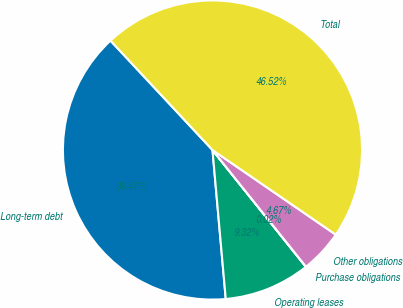<chart> <loc_0><loc_0><loc_500><loc_500><pie_chart><fcel>Long-term debt<fcel>Operating leases<fcel>Purchase obligations<fcel>Other obligations<fcel>Total<nl><fcel>39.47%<fcel>9.32%<fcel>0.02%<fcel>4.67%<fcel>46.52%<nl></chart> 